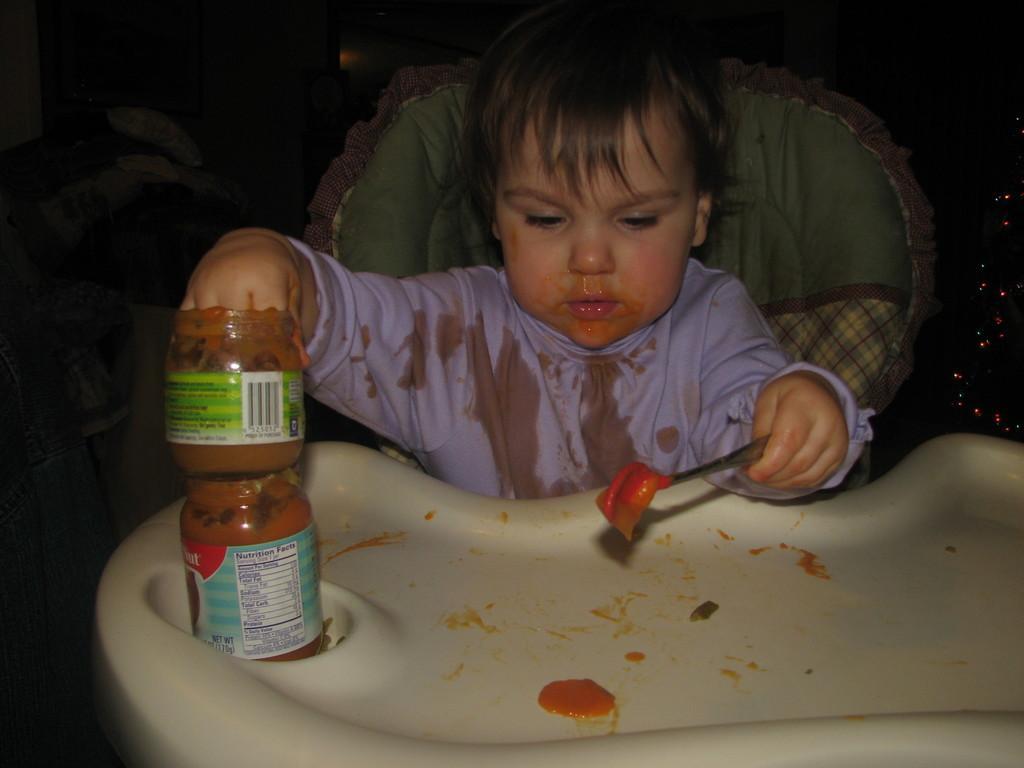Describe this image in one or two sentences. In this image a kid is sitting on his chair and holding a jar with jam in it and in the another hand he is holding a spoon. 